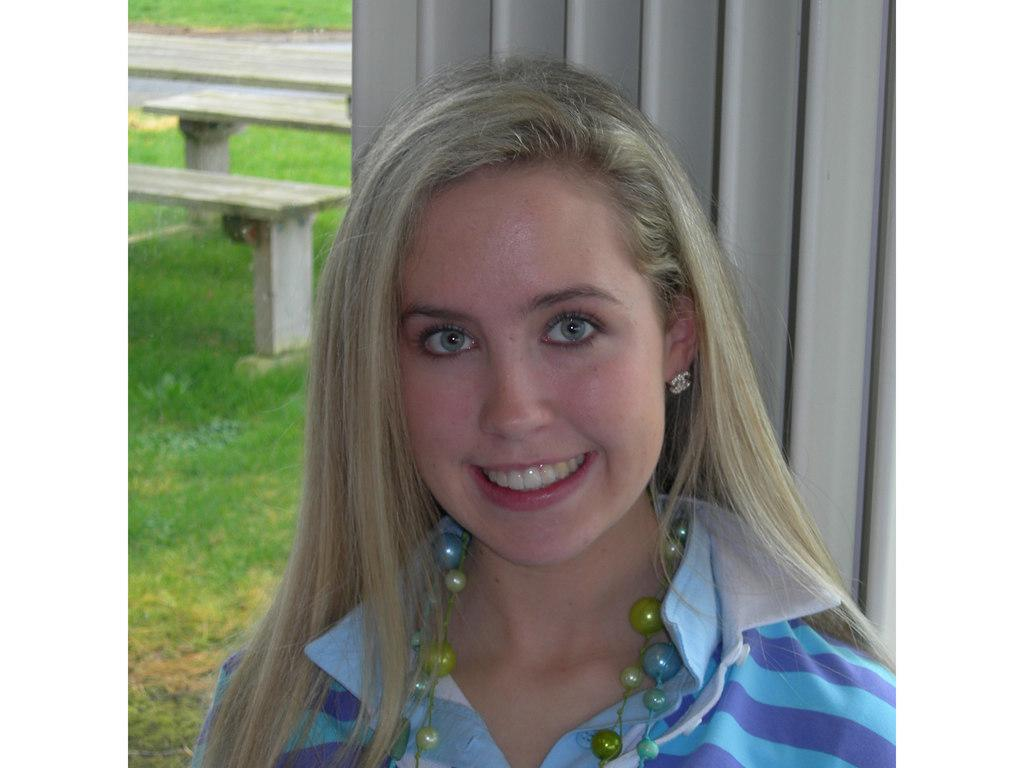What is the main subject of the image? There is a woman standing in the middle of the image. What is the woman's expression in the image? The woman is smiling in the image. What can be seen behind the woman? There is a wall behind the woman. What type of vegetation is on the left side of the image? There is grass on the left side of the image. What type of furniture is on the left side of the image? There are benches on the left side of the image. What type of stamp can be seen on the woman's forehead in the image? There is no stamp visible on the woman's forehead in the image. What invention is the woman holding in her hand in the image? The image does not show the woman holding any invention in her hand. 